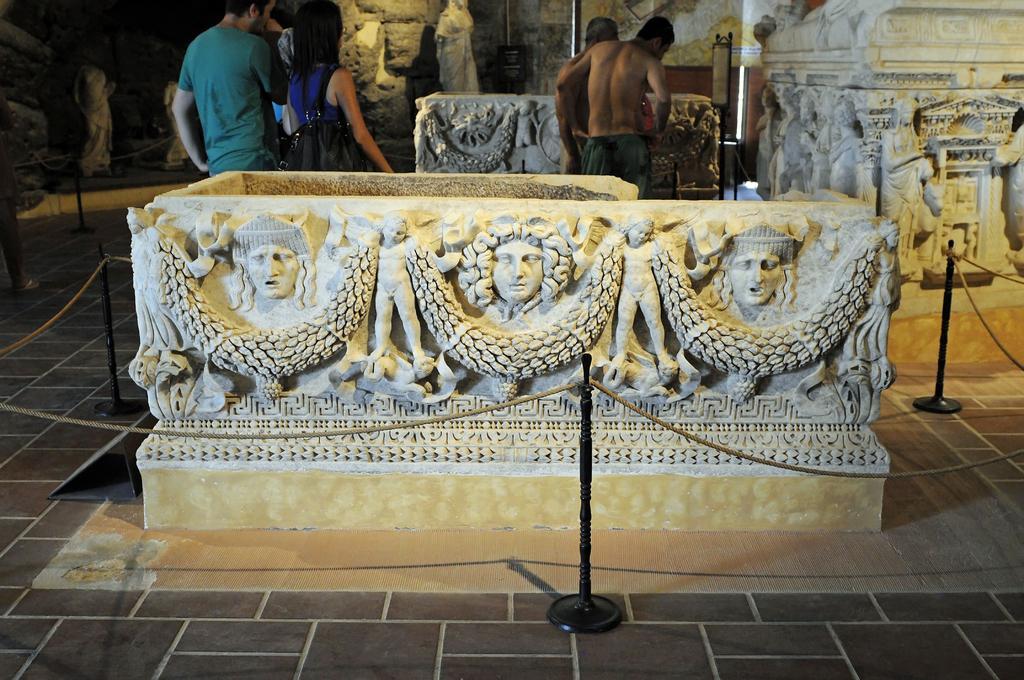How would you summarize this image in a sentence or two? This picture seems to be clicked inside. We can see there are many number of sculptures and we can see the rope and metal stands. In background we can see the group of persons standing on the ground, we can see the wall, sculptures and some other items. 